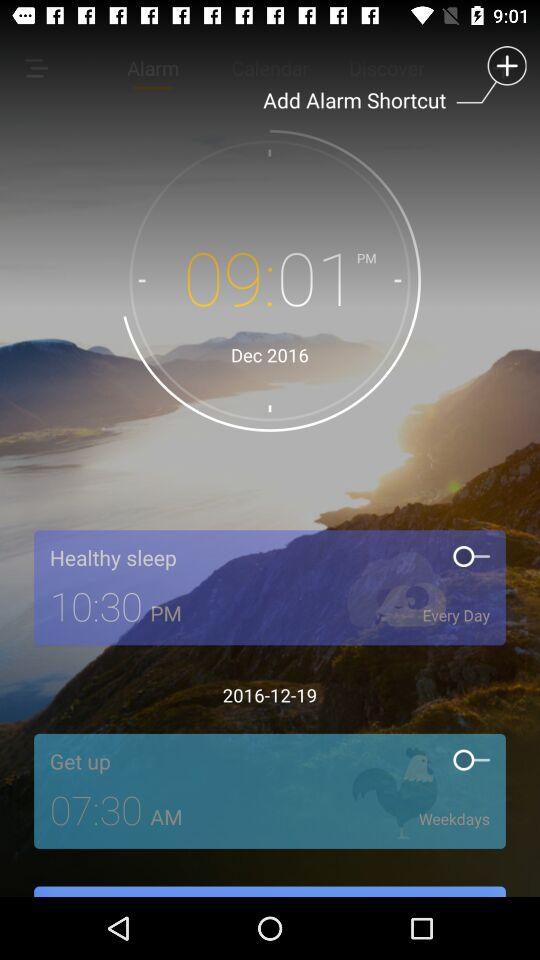How many alarms are there?
Answer the question using a single word or phrase. 2 